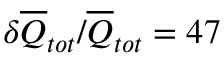Convert formula to latex. <formula><loc_0><loc_0><loc_500><loc_500>\delta \overline { Q } _ { t o t } / \overline { Q } _ { t o t } = 4 7 \, \</formula> 